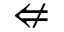Convert formula to latex. <formula><loc_0><loc_0><loc_500><loc_500>\ n L e f t a r r o w</formula> 